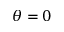Convert formula to latex. <formula><loc_0><loc_0><loc_500><loc_500>\theta = 0</formula> 